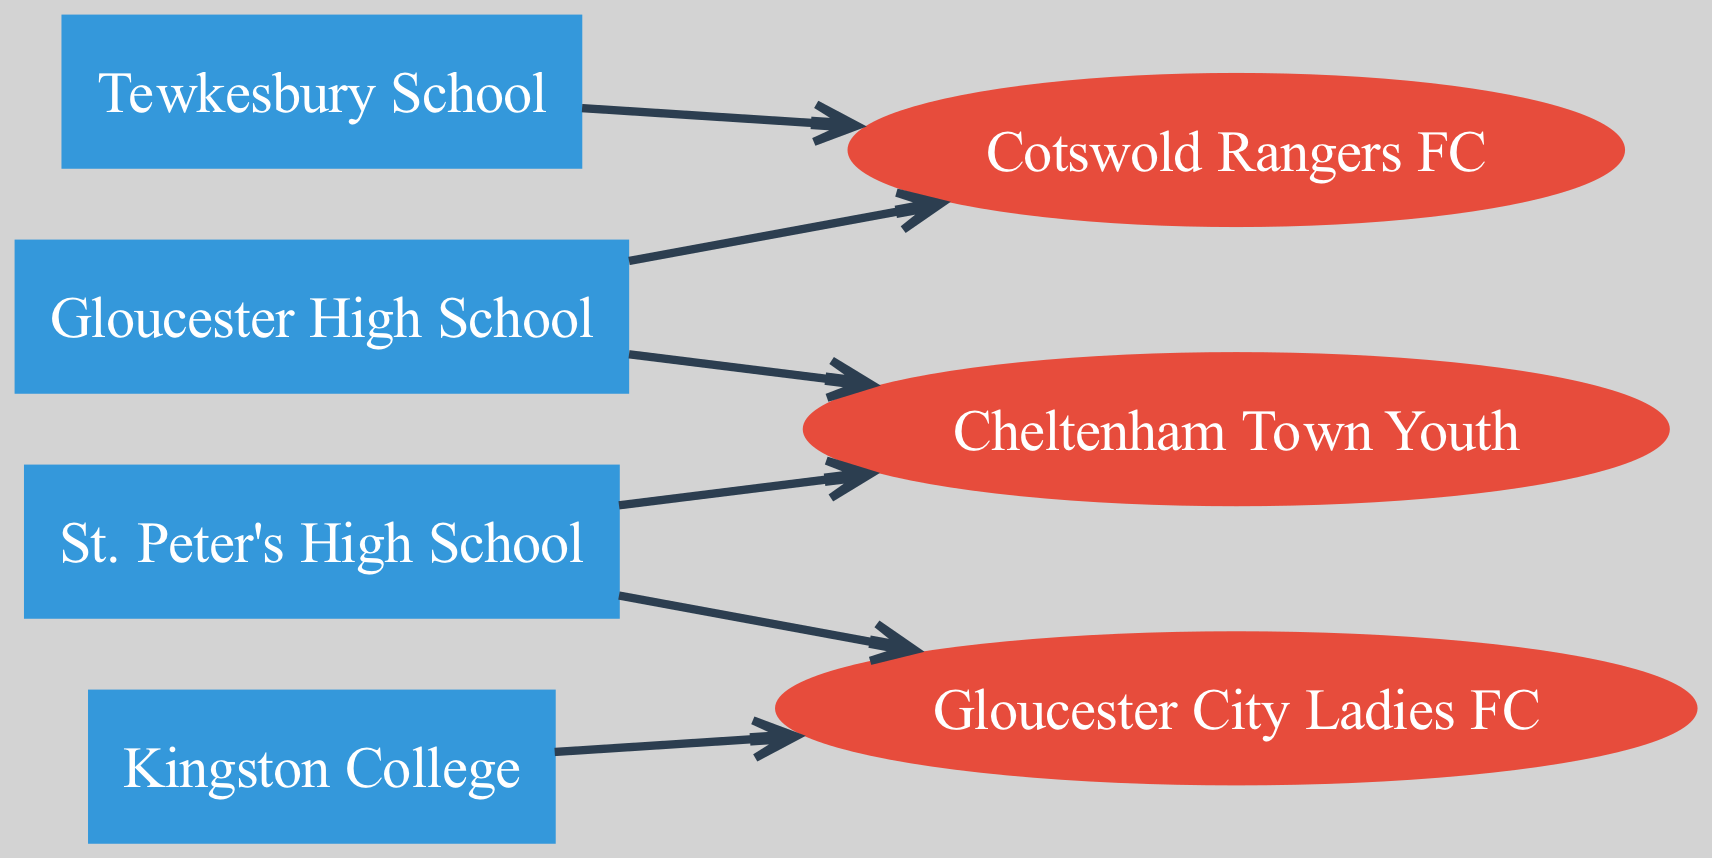What are the total number of high schools depicted in the diagram? To find the total number of high schools, we can count the nodes listed in the schools category. The diagram includes Gloucester High School, Kingston College, Tewkesbury School, and St. Peter's High School, making a total of four high schools.
Answer: 4 Which club is associated with Gloucester High School? The edge directed from Gloucester High School leads to the nodes representing feeder clubs. The diagram shows that Gloucester High School is connected to Cotswold Rangers and Cheltenham Town Youth, indicating these two clubs are directly associated with Gloucester High School.
Answer: Cotswold Rangers, Cheltenham Town Youth How many feeder clubs are identified in the diagram? By analyzing the edges connected to clubs, we count the clubs connected to high schools. The clubs listed are Cotswold Rangers FC, Gloucester City Ladies FC, and Cheltenham Town Youth. Thus, there are three feeder clubs in total.
Answer: 3 Which school has connections to Gloucester City Ladies FC? We can identify the high schools that have an edge directed toward Gloucester City Ladies FC by tracing the edges in the diagram. The diagram indicates that Kingston College and St. Peter's High School both have connections to Gloucester City Ladies FC.
Answer: Kingston College, St. Peter's High School How many nodes denote feeder clubs in the diagram? To determine the number of feeder club nodes, we can look specifically at the nodes that are categorized as clubs. In the data, we see Cotswold Rangers FC, Gloucester City Ladies FC, and Cheltenham Town Youth, showing there are three nodes representing feeder clubs.
Answer: 3 Which high school is linked to Cotswold Rangers FC? By following the directed edges from high schools to clubs, it's clear that both Gloucester High School and Tewkesbury School are connected to Cotswold Rangers FC according to the diagram.
Answer: Gloucester High School, Tewkesbury School What is the direction of the edge between St. Peter's High School and Cheltenham Town Youth? The diagram indicates a directed edge from St. Peter's High School to Cheltenham Town Youth, meaning the flow of the relationship is that St. Peter's High School feeds into Cheltenham Town Youth.
Answer: From St. Peter's High School to Cheltenham Town Youth How many directed edges originate from Tewkesbury School? To find out how many directed edges originate from Tewkesbury School, we can look for incoming arrows to the nodes from Tewkesbury School. The only edge directed from Tewkesbury School is towards Cotswold Rangers, which indicates a single originating edge.
Answer: 1 Which high school has the most connections to feeder clubs? Analyzing the directed edges, Gloucester High School has two connections (Cotswold Rangers and Cheltenham Town Youth), Kingston College has one (Gloucester City Ladies), Tewkesbury School has one (Cotswold Rangers), and St. Peter's High School has two (Cheltenham Town Youth and Gloucester City Ladies). Thus, both Gloucester High School and St. Peter's High School have the most connections with two each.
Answer: Gloucester High School, St. Peter's High School 